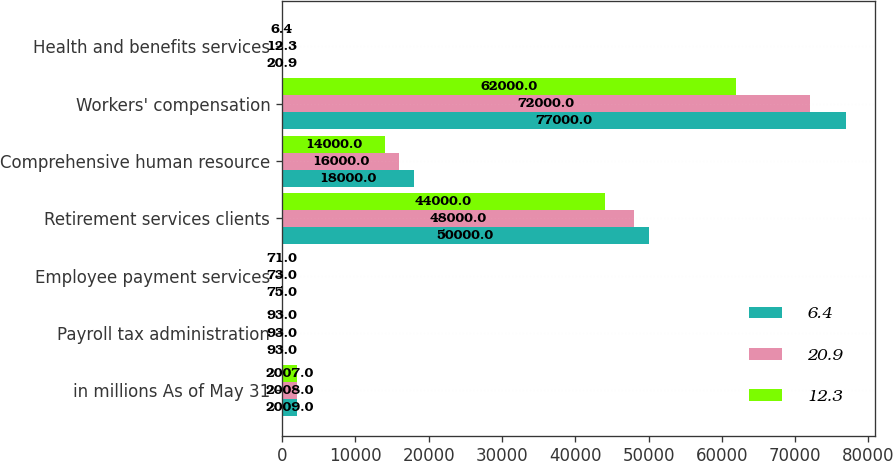<chart> <loc_0><loc_0><loc_500><loc_500><stacked_bar_chart><ecel><fcel>in millions As of May 31<fcel>Payroll tax administration<fcel>Employee payment services<fcel>Retirement services clients<fcel>Comprehensive human resource<fcel>Workers' compensation<fcel>Health and benefits services<nl><fcel>6.4<fcel>2009<fcel>93<fcel>75<fcel>50000<fcel>18000<fcel>77000<fcel>20.9<nl><fcel>20.9<fcel>2008<fcel>93<fcel>73<fcel>48000<fcel>16000<fcel>72000<fcel>12.3<nl><fcel>12.3<fcel>2007<fcel>93<fcel>71<fcel>44000<fcel>14000<fcel>62000<fcel>6.4<nl></chart> 